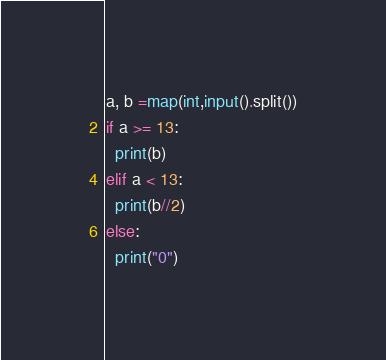<code> <loc_0><loc_0><loc_500><loc_500><_Python_>a, b =map(int,input().split())
if a >= 13:
  print(b)
elif a < 13:
  print(b//2)
else:
  print("0")</code> 